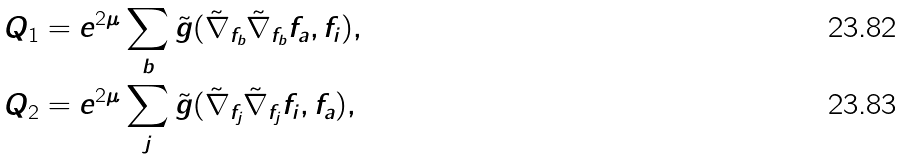<formula> <loc_0><loc_0><loc_500><loc_500>Q _ { 1 } & = e ^ { 2 \mu } \sum _ { b } \tilde { g } ( \tilde { \nabla } _ { f _ { b } } \tilde { \nabla } _ { f _ { b } } f _ { a } , f _ { i } ) , \\ Q _ { 2 } & = e ^ { 2 \mu } \sum _ { j } \tilde { g } ( \tilde { \nabla } _ { f _ { j } } \tilde { \nabla } _ { f _ { j } } f _ { i } , f _ { a } ) ,</formula> 